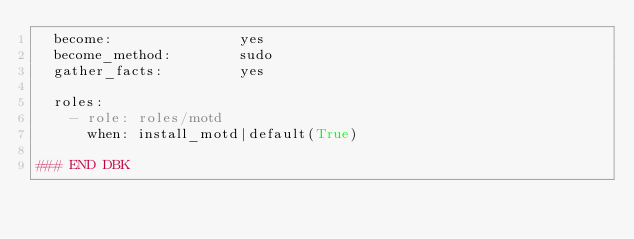Convert code to text. <code><loc_0><loc_0><loc_500><loc_500><_YAML_>  become:               yes
  become_method:        sudo
  gather_facts:         yes

  roles:
    - role: roles/motd
      when: install_motd|default(True)

### END DBK
</code> 